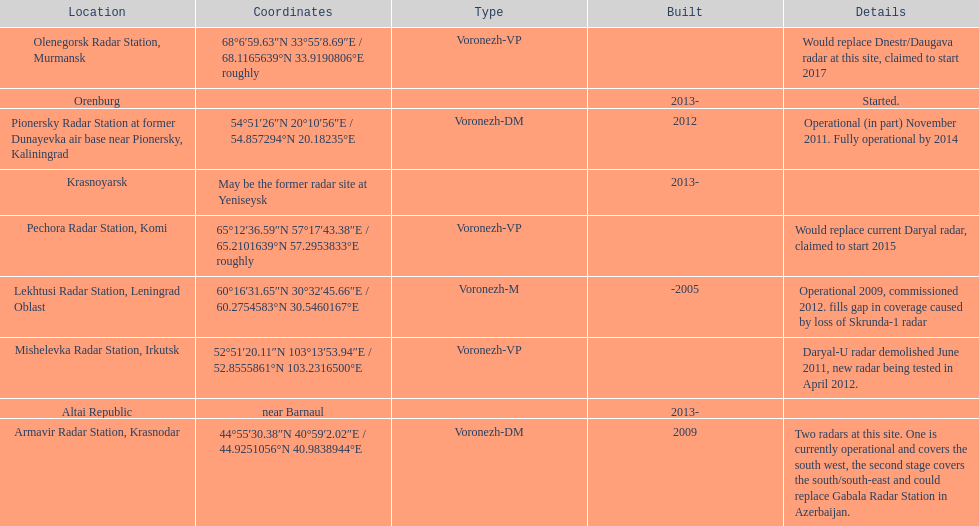How long did it take the pionersky radar station to go from partially operational to fully operational? 3 years. 